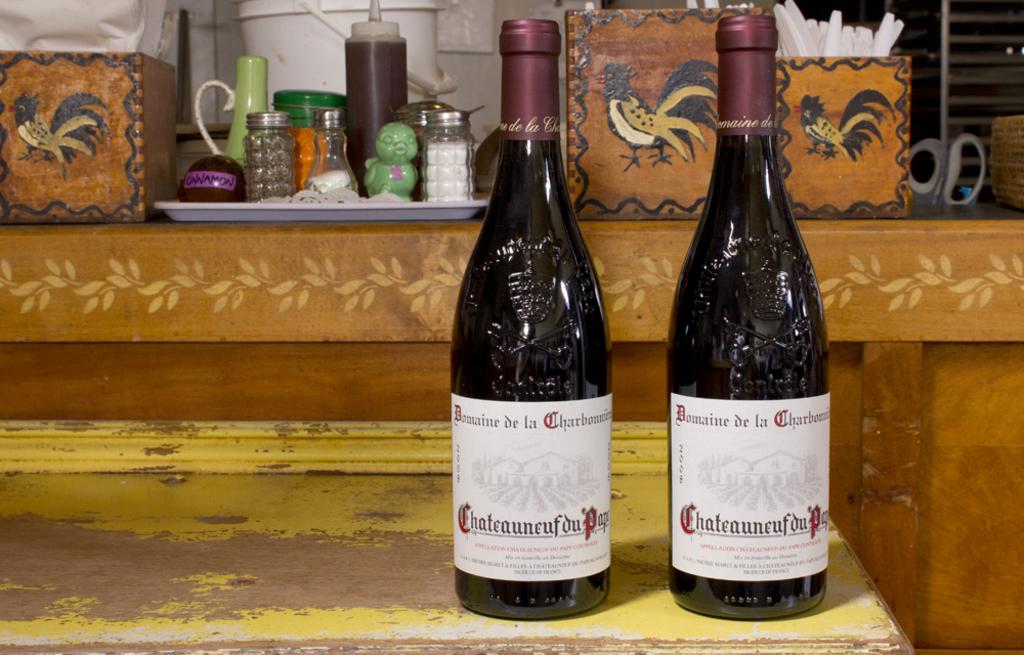What spice is shown on the purple tag?
Your response must be concise. Cinnamon. 